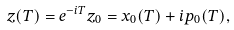<formula> <loc_0><loc_0><loc_500><loc_500>z ( T ) = e ^ { - i T } z _ { 0 } = x _ { 0 } ( T ) + i p _ { 0 } ( T ) ,</formula> 